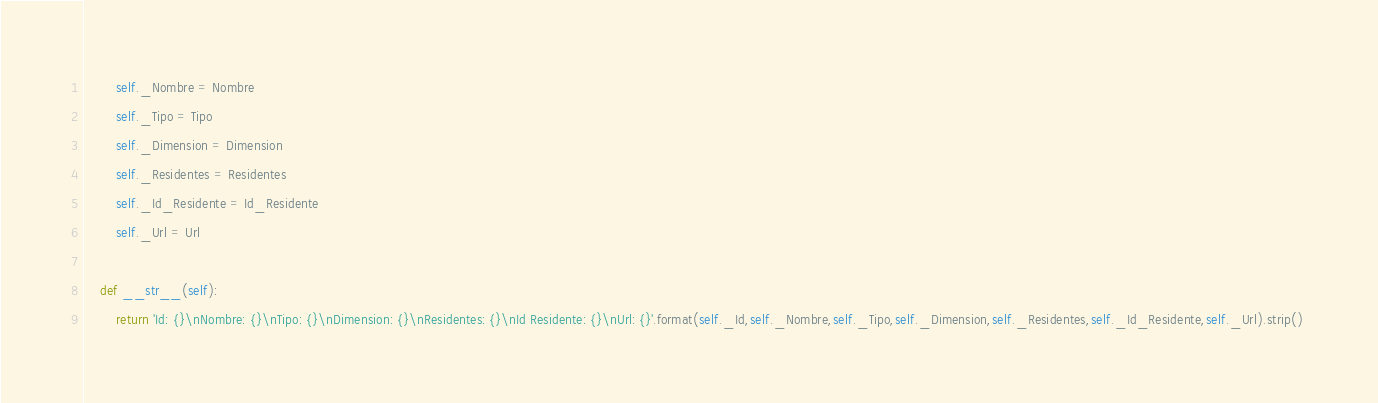Convert code to text. <code><loc_0><loc_0><loc_500><loc_500><_Python_>        self._Nombre = Nombre
        self._Tipo = Tipo
        self._Dimension = Dimension
        self._Residentes = Residentes
        self._Id_Residente = Id_Residente
        self._Url = Url

    def __str__(self):
        return 'Id: {}\nNombre: {}\nTipo: {}\nDimension: {}\nResidentes: {}\nId Residente: {}\nUrl: {}'.format(self._Id,self._Nombre,self._Tipo,self._Dimension,self._Residentes,self._Id_Residente,self._Url).strip() </code> 